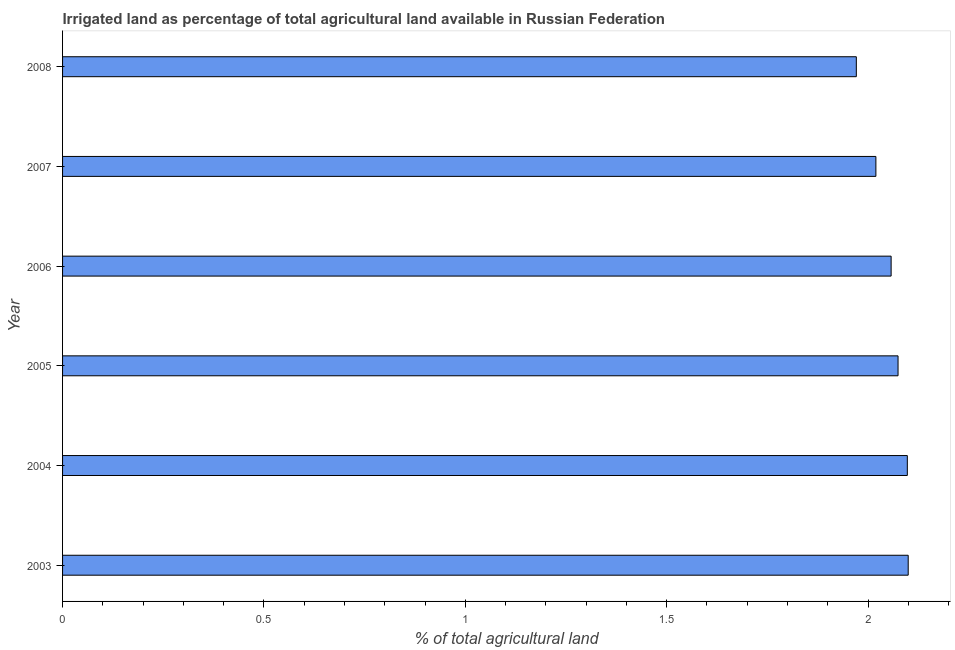Does the graph contain any zero values?
Provide a succinct answer. No. Does the graph contain grids?
Ensure brevity in your answer.  No. What is the title of the graph?
Your answer should be compact. Irrigated land as percentage of total agricultural land available in Russian Federation. What is the label or title of the X-axis?
Your response must be concise. % of total agricultural land. What is the label or title of the Y-axis?
Your answer should be very brief. Year. What is the percentage of agricultural irrigated land in 2007?
Your response must be concise. 2.02. Across all years, what is the maximum percentage of agricultural irrigated land?
Your response must be concise. 2.1. Across all years, what is the minimum percentage of agricultural irrigated land?
Keep it short and to the point. 1.97. In which year was the percentage of agricultural irrigated land maximum?
Provide a short and direct response. 2003. In which year was the percentage of agricultural irrigated land minimum?
Offer a very short reply. 2008. What is the sum of the percentage of agricultural irrigated land?
Keep it short and to the point. 12.32. What is the difference between the percentage of agricultural irrigated land in 2003 and 2004?
Provide a short and direct response. 0. What is the average percentage of agricultural irrigated land per year?
Give a very brief answer. 2.05. What is the median percentage of agricultural irrigated land?
Your answer should be compact. 2.07. Do a majority of the years between 2007 and 2005 (inclusive) have percentage of agricultural irrigated land greater than 0.3 %?
Offer a very short reply. Yes. What is the ratio of the percentage of agricultural irrigated land in 2004 to that in 2006?
Keep it short and to the point. 1.02. Is the percentage of agricultural irrigated land in 2004 less than that in 2008?
Your answer should be compact. No. Is the difference between the percentage of agricultural irrigated land in 2004 and 2007 greater than the difference between any two years?
Give a very brief answer. No. What is the difference between the highest and the second highest percentage of agricultural irrigated land?
Your answer should be compact. 0. Is the sum of the percentage of agricultural irrigated land in 2005 and 2007 greater than the maximum percentage of agricultural irrigated land across all years?
Give a very brief answer. Yes. What is the difference between the highest and the lowest percentage of agricultural irrigated land?
Offer a very short reply. 0.13. How many bars are there?
Your answer should be very brief. 6. What is the % of total agricultural land of 2003?
Your response must be concise. 2.1. What is the % of total agricultural land in 2004?
Your answer should be compact. 2.1. What is the % of total agricultural land in 2005?
Provide a short and direct response. 2.07. What is the % of total agricultural land of 2006?
Give a very brief answer. 2.06. What is the % of total agricultural land in 2007?
Ensure brevity in your answer.  2.02. What is the % of total agricultural land of 2008?
Your answer should be very brief. 1.97. What is the difference between the % of total agricultural land in 2003 and 2004?
Give a very brief answer. 0. What is the difference between the % of total agricultural land in 2003 and 2005?
Offer a very short reply. 0.03. What is the difference between the % of total agricultural land in 2003 and 2006?
Offer a very short reply. 0.04. What is the difference between the % of total agricultural land in 2003 and 2007?
Offer a very short reply. 0.08. What is the difference between the % of total agricultural land in 2003 and 2008?
Ensure brevity in your answer.  0.13. What is the difference between the % of total agricultural land in 2004 and 2005?
Offer a terse response. 0.02. What is the difference between the % of total agricultural land in 2004 and 2006?
Your answer should be very brief. 0.04. What is the difference between the % of total agricultural land in 2004 and 2007?
Offer a terse response. 0.08. What is the difference between the % of total agricultural land in 2004 and 2008?
Your answer should be very brief. 0.13. What is the difference between the % of total agricultural land in 2005 and 2006?
Provide a short and direct response. 0.02. What is the difference between the % of total agricultural land in 2005 and 2007?
Give a very brief answer. 0.06. What is the difference between the % of total agricultural land in 2005 and 2008?
Your response must be concise. 0.1. What is the difference between the % of total agricultural land in 2006 and 2007?
Make the answer very short. 0.04. What is the difference between the % of total agricultural land in 2006 and 2008?
Keep it short and to the point. 0.09. What is the difference between the % of total agricultural land in 2007 and 2008?
Ensure brevity in your answer.  0.05. What is the ratio of the % of total agricultural land in 2003 to that in 2004?
Your response must be concise. 1. What is the ratio of the % of total agricultural land in 2003 to that in 2006?
Offer a terse response. 1.02. What is the ratio of the % of total agricultural land in 2003 to that in 2008?
Your answer should be compact. 1.06. What is the ratio of the % of total agricultural land in 2004 to that in 2007?
Provide a succinct answer. 1.04. What is the ratio of the % of total agricultural land in 2004 to that in 2008?
Keep it short and to the point. 1.06. What is the ratio of the % of total agricultural land in 2005 to that in 2007?
Provide a short and direct response. 1.03. What is the ratio of the % of total agricultural land in 2005 to that in 2008?
Give a very brief answer. 1.05. What is the ratio of the % of total agricultural land in 2006 to that in 2008?
Give a very brief answer. 1.04. What is the ratio of the % of total agricultural land in 2007 to that in 2008?
Provide a succinct answer. 1.02. 